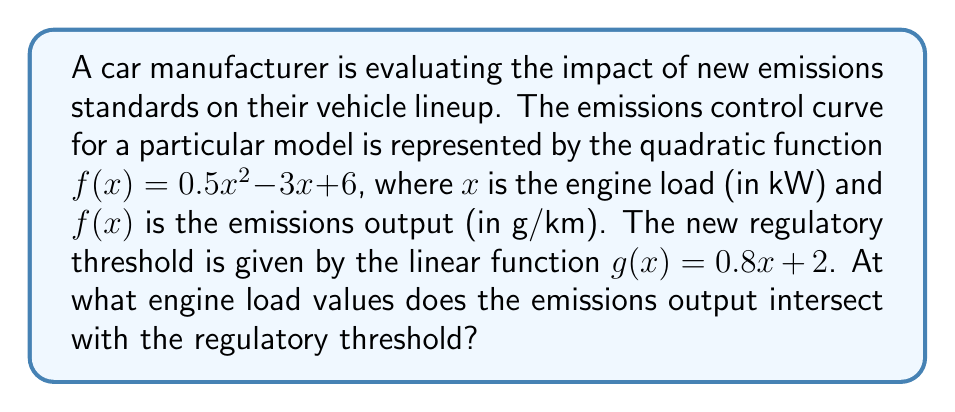Help me with this question. To find the intersection points, we need to solve the equation $f(x) = g(x)$:

$$0.5x^2 - 3x + 6 = 0.8x + 2$$

Rearranging the equation:

$$0.5x^2 - 3.8x + 4 = 0$$

This is a quadratic equation in the form $ax^2 + bx + c = 0$, where:
$a = 0.5$
$b = -3.8$
$c = 4$

We can solve this using the quadratic formula: $x = \frac{-b \pm \sqrt{b^2 - 4ac}}{2a}$

Substituting the values:

$$x = \frac{3.8 \pm \sqrt{(-3.8)^2 - 4(0.5)(4)}}{2(0.5)}$$

$$x = \frac{3.8 \pm \sqrt{14.44 - 8}}{1}$$

$$x = \frac{3.8 \pm \sqrt{6.44}}{1}$$

$$x = \frac{3.8 \pm 2.54}{1}$$

This gives us two solutions:

$$x_1 = 3.8 + 2.54 = 6.34$$
$$x_2 = 3.8 - 2.54 = 1.26$$

Therefore, the emissions output intersects with the regulatory threshold at engine load values of approximately 1.26 kW and 6.34 kW.
Answer: The intersection points occur at engine load values of approximately 1.26 kW and 6.34 kW. 